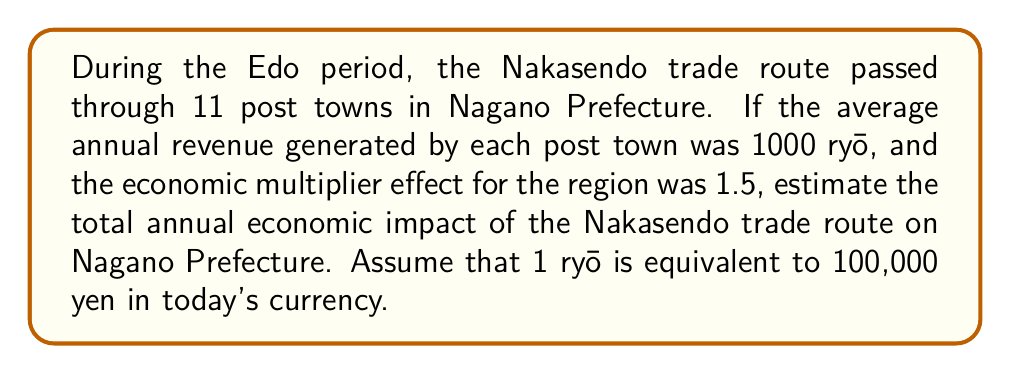Show me your answer to this math problem. To solve this problem, we'll follow these steps:

1. Calculate the total direct revenue from all post towns:
   $$R = 11 \text{ towns} \times 1000 \text{ ryō/town} = 11,000 \text{ ryō}$$

2. Apply the economic multiplier effect:
   $$E = R \times 1.5 = 11,000 \times 1.5 = 16,500 \text{ ryō}$$

3. Convert the result to modern yen:
   $$Y = E \times 100,000 \text{ yen/ryō} = 16,500 \times 100,000 = 1,650,000,000 \text{ yen}$$

Therefore, the estimated annual economic impact of the Nakasendo trade route on Nagano Prefecture during the Edo period, in terms of modern currency, is 1,650,000,000 yen.
Answer: 1,650,000,000 yen 